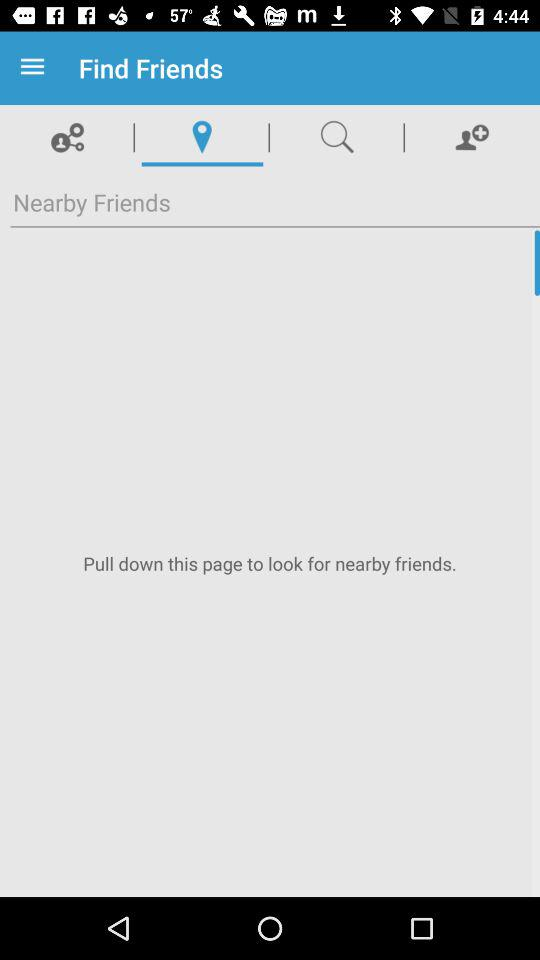Which tab is selected? The selected tab is "Location". 